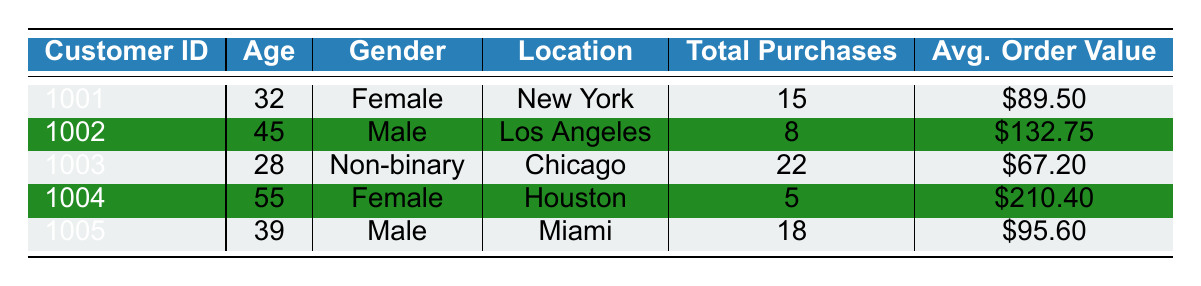What is the average age of the customers? To find the average age, we add each customer's age: 32 + 45 + 28 + 55 + 39 = 199. Then, divide by the number of customers (5), which gives us 199 / 5 = 39.8.
Answer: 39.8 Which customer has the highest average order value? By examining the average order value, we see the values are $89.50, $132.75, $67.20, $210.40, and $95.60. The highest value is $210.40 for customer 1004.
Answer: Customer 1004 How many total purchases did customer 1003 make? The total purchases for customer 1003 is explicitly listed in the table as 22.
Answer: 22 Is customer 1002 a member of the loyalty program? The table indicates that customer 1002 does not have a loyalty program membership (listed as false).
Answer: No What is the median age of the customers? To find the median age, we need to sort the ages: 28, 32, 39, 45, 55. The middle value (3rd in a list of 5) is 39.
Answer: 39 How many customers made more than 10 total purchases? The customers with total purchases are 15, 8, 22, 5, and 18. The counts that are greater than 10 are 15, 22, and 18, which sums up to 3 customers.
Answer: 3 Which location has the oldest customer? The ages are 32 in New York, 45 in Los Angeles, 28 in Chicago, 55 in Houston, and 39 in Miami. The oldest customer is from Houston at 55 years old.
Answer: Houston Is there any non-binary customer in the data? The table lists customer 1003 as Non-binary. Thus, there is at least one non-binary customer.
Answer: Yes What is the total average order value across all customers? The total average order values are $89.50, $132.75, $67.20, $210.40, and $95.60. We sum these: $89.50 + $132.75 + $67.20 + $210.40 + $95.60 = $595.45. We then divide by 5: $595.45 / 5 = $119.09.
Answer: $119.09 What percentage of customers are enrolled in the loyalty program? There are 5 customers in total, and 3 of them (customers 1001, 1003, and 1005) are enrolled in the loyalty program. Thus, the percentage is 3 / 5 * 100 = 60%.
Answer: 60% 